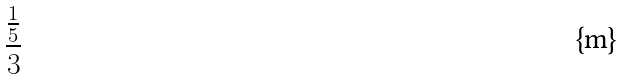Convert formula to latex. <formula><loc_0><loc_0><loc_500><loc_500>\frac { \frac { 1 } { 5 } } { 3 }</formula> 